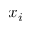Convert formula to latex. <formula><loc_0><loc_0><loc_500><loc_500>x _ { i }</formula> 